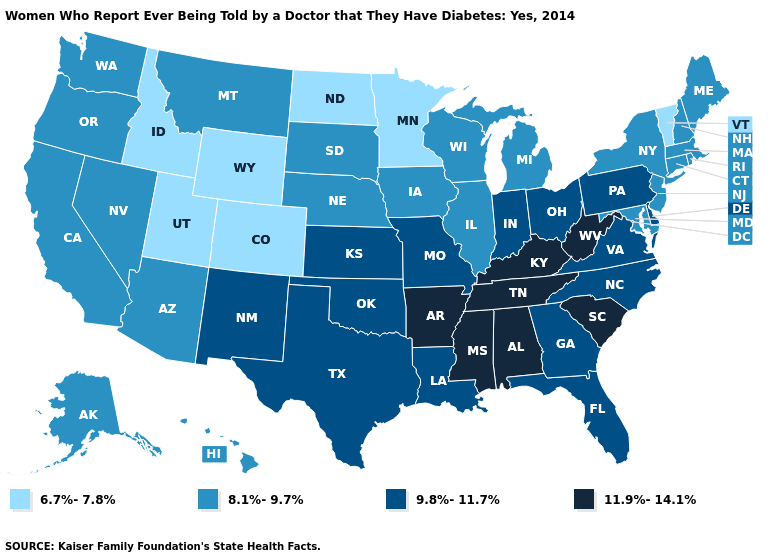How many symbols are there in the legend?
Answer briefly. 4. Does the first symbol in the legend represent the smallest category?
Answer briefly. Yes. Does West Virginia have the highest value in the South?
Concise answer only. Yes. Which states have the lowest value in the West?
Short answer required. Colorado, Idaho, Utah, Wyoming. Name the states that have a value in the range 8.1%-9.7%?
Keep it brief. Alaska, Arizona, California, Connecticut, Hawaii, Illinois, Iowa, Maine, Maryland, Massachusetts, Michigan, Montana, Nebraska, Nevada, New Hampshire, New Jersey, New York, Oregon, Rhode Island, South Dakota, Washington, Wisconsin. What is the lowest value in the USA?
Keep it brief. 6.7%-7.8%. Does Colorado have the lowest value in the USA?
Quick response, please. Yes. Name the states that have a value in the range 9.8%-11.7%?
Answer briefly. Delaware, Florida, Georgia, Indiana, Kansas, Louisiana, Missouri, New Mexico, North Carolina, Ohio, Oklahoma, Pennsylvania, Texas, Virginia. Among the states that border Nevada , does Idaho have the lowest value?
Short answer required. Yes. Name the states that have a value in the range 9.8%-11.7%?
Short answer required. Delaware, Florida, Georgia, Indiana, Kansas, Louisiana, Missouri, New Mexico, North Carolina, Ohio, Oklahoma, Pennsylvania, Texas, Virginia. What is the value of Illinois?
Give a very brief answer. 8.1%-9.7%. What is the lowest value in the Northeast?
Keep it brief. 6.7%-7.8%. Name the states that have a value in the range 9.8%-11.7%?
Short answer required. Delaware, Florida, Georgia, Indiana, Kansas, Louisiana, Missouri, New Mexico, North Carolina, Ohio, Oklahoma, Pennsylvania, Texas, Virginia. Name the states that have a value in the range 8.1%-9.7%?
Answer briefly. Alaska, Arizona, California, Connecticut, Hawaii, Illinois, Iowa, Maine, Maryland, Massachusetts, Michigan, Montana, Nebraska, Nevada, New Hampshire, New Jersey, New York, Oregon, Rhode Island, South Dakota, Washington, Wisconsin. Does Nebraska have the lowest value in the MidWest?
Concise answer only. No. 